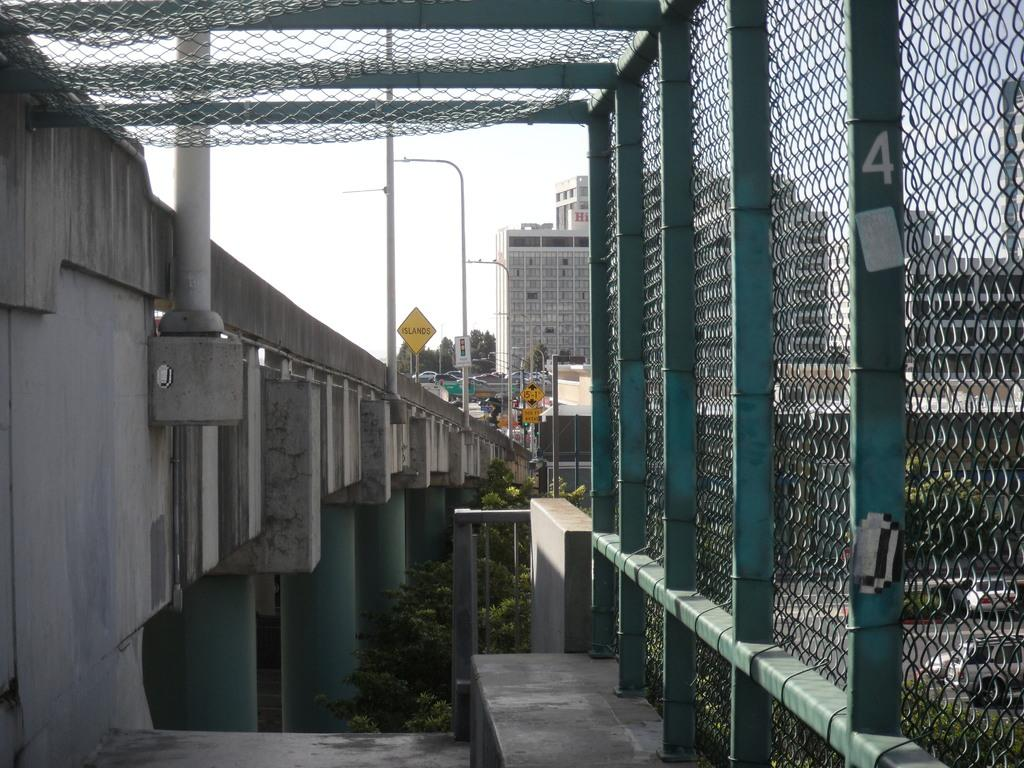What can be seen on the right side of the image? There is a mesh on the right side of the image. What type of structures are visible in the image? There are buildings in the image. What lighting elements are present in the image? Street lights are present in the image. What type of signage can be seen in the image? Sign boards are visible in the image. What mode of transportation is present in the image? Vehicles are in the image, including cars. What type of architectural feature is present in the image? There is a bridge in the image. What structural elements support the bridge? Pillars are present in the image. What type of vegetation is visible in the image? Trees are visible in the image. What part of the natural environment is visible in the image? The sky is visible in the image. Can you hear the whistle of the wind in the image? There is no auditory information provided in the image, so it is not possible to determine if the wind is whistling. What type of action is being performed by the angle in the image? There is no angle present in the image, so it is not possible to determine any actions being performed by an angle. 